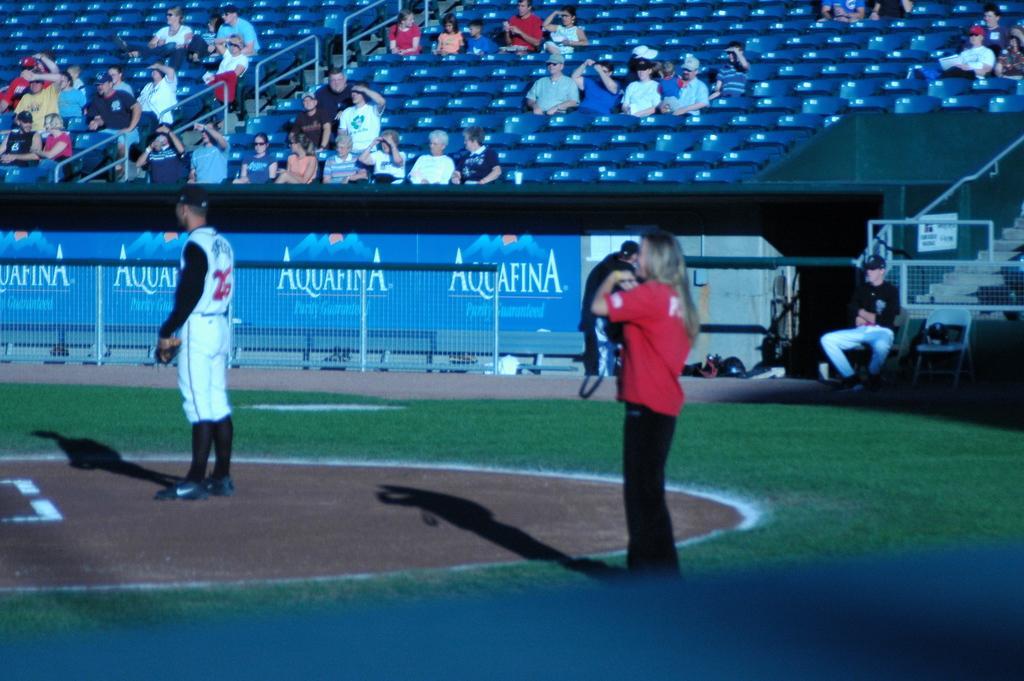Describe this image in one or two sentences. In the picture I can see a person wearing red color T-shirt and a person wearing white color dress are standing in the ground. In the background, I can see a person standing, a person is sitting on the chair, I can see the fence, boards and a few people are sitting on the chairs in the stadium. 